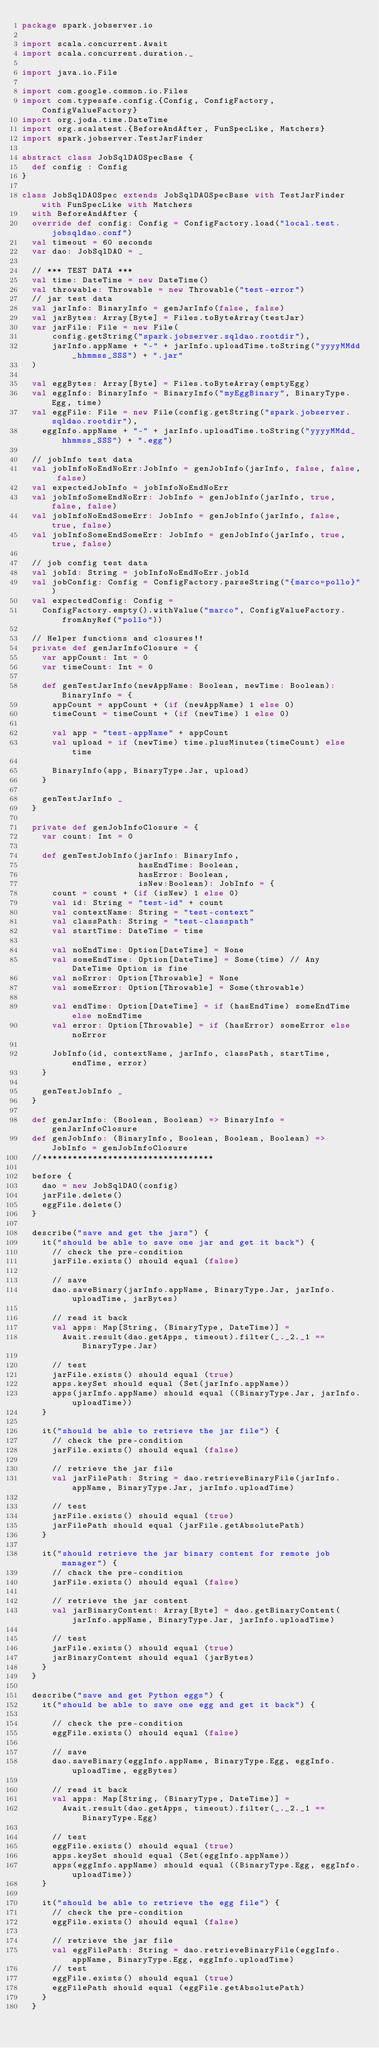Convert code to text. <code><loc_0><loc_0><loc_500><loc_500><_Scala_>package spark.jobserver.io

import scala.concurrent.Await
import scala.concurrent.duration._

import java.io.File

import com.google.common.io.Files
import com.typesafe.config.{Config, ConfigFactory, ConfigValueFactory}
import org.joda.time.DateTime
import org.scalatest.{BeforeAndAfter, FunSpecLike, Matchers}
import spark.jobserver.TestJarFinder

abstract class JobSqlDAOSpecBase {
  def config : Config
}

class JobSqlDAOSpec extends JobSqlDAOSpecBase with TestJarFinder with FunSpecLike with Matchers
  with BeforeAndAfter {
  override def config: Config = ConfigFactory.load("local.test.jobsqldao.conf")
  val timeout = 60 seconds
  var dao: JobSqlDAO = _

  // *** TEST DATA ***
  val time: DateTime = new DateTime()
  val throwable: Throwable = new Throwable("test-error")
  // jar test data
  val jarInfo: BinaryInfo = genJarInfo(false, false)
  val jarBytes: Array[Byte] = Files.toByteArray(testJar)
  var jarFile: File = new File(
      config.getString("spark.jobserver.sqldao.rootdir"),
      jarInfo.appName + "-" + jarInfo.uploadTime.toString("yyyyMMdd_hhmmss_SSS") + ".jar"
  )

  val eggBytes: Array[Byte] = Files.toByteArray(emptyEgg)
  val eggInfo: BinaryInfo = BinaryInfo("myEggBinary", BinaryType.Egg, time)
  val eggFile: File = new File(config.getString("spark.jobserver.sqldao.rootdir"),
    eggInfo.appName + "-" + jarInfo.uploadTime.toString("yyyyMMdd_hhmmss_SSS") + ".egg")

  // jobInfo test data
  val jobInfoNoEndNoErr:JobInfo = genJobInfo(jarInfo, false, false, false)
  val expectedJobInfo = jobInfoNoEndNoErr
  val jobInfoSomeEndNoErr: JobInfo = genJobInfo(jarInfo, true, false, false)
  val jobInfoNoEndSomeErr: JobInfo = genJobInfo(jarInfo, false, true, false)
  val jobInfoSomeEndSomeErr: JobInfo = genJobInfo(jarInfo, true, true, false)

  // job config test data
  val jobId: String = jobInfoNoEndNoErr.jobId
  val jobConfig: Config = ConfigFactory.parseString("{marco=pollo}")
  val expectedConfig: Config =
    ConfigFactory.empty().withValue("marco", ConfigValueFactory.fromAnyRef("pollo"))

  // Helper functions and closures!!
  private def genJarInfoClosure = {
    var appCount: Int = 0
    var timeCount: Int = 0

    def genTestJarInfo(newAppName: Boolean, newTime: Boolean): BinaryInfo = {
      appCount = appCount + (if (newAppName) 1 else 0)
      timeCount = timeCount + (if (newTime) 1 else 0)

      val app = "test-appName" + appCount
      val upload = if (newTime) time.plusMinutes(timeCount) else time

      BinaryInfo(app, BinaryType.Jar, upload)
    }

    genTestJarInfo _
  }

  private def genJobInfoClosure = {
    var count: Int = 0

    def genTestJobInfo(jarInfo: BinaryInfo,
                       hasEndTime: Boolean,
                       hasError: Boolean,
                       isNew:Boolean): JobInfo = {
      count = count + (if (isNew) 1 else 0)
      val id: String = "test-id" + count
      val contextName: String = "test-context"
      val classPath: String = "test-classpath"
      val startTime: DateTime = time

      val noEndTime: Option[DateTime] = None
      val someEndTime: Option[DateTime] = Some(time) // Any DateTime Option is fine
      val noError: Option[Throwable] = None
      val someError: Option[Throwable] = Some(throwable)

      val endTime: Option[DateTime] = if (hasEndTime) someEndTime else noEndTime
      val error: Option[Throwable] = if (hasError) someError else noError

      JobInfo(id, contextName, jarInfo, classPath, startTime, endTime, error)
    }

    genTestJobInfo _
  }

  def genJarInfo: (Boolean, Boolean) => BinaryInfo = genJarInfoClosure
  def genJobInfo: (BinaryInfo, Boolean, Boolean, Boolean) => JobInfo = genJobInfoClosure
  //**********************************

  before {
    dao = new JobSqlDAO(config)
    jarFile.delete()
    eggFile.delete()
  }

  describe("save and get the jars") {
    it("should be able to save one jar and get it back") {
      // check the pre-condition
      jarFile.exists() should equal (false)

      // save
      dao.saveBinary(jarInfo.appName, BinaryType.Jar, jarInfo.uploadTime, jarBytes)

      // read it back
      val apps: Map[String, (BinaryType, DateTime)] =
        Await.result(dao.getApps, timeout).filter(_._2._1 == BinaryType.Jar)

      // test
      jarFile.exists() should equal (true)
      apps.keySet should equal (Set(jarInfo.appName))
      apps(jarInfo.appName) should equal ((BinaryType.Jar, jarInfo.uploadTime))
    }

    it("should be able to retrieve the jar file") {
      // check the pre-condition
      jarFile.exists() should equal (false)

      // retrieve the jar file
      val jarFilePath: String = dao.retrieveBinaryFile(jarInfo.appName, BinaryType.Jar, jarInfo.uploadTime)

      // test
      jarFile.exists() should equal (true)
      jarFilePath should equal (jarFile.getAbsolutePath)
    }

    it("should retrieve the jar binary content for remote job manager") {
      // chack the pre-condition
      jarFile.exists() should equal (false)

      // retrieve the jar content
      val jarBinaryContent: Array[Byte] = dao.getBinaryContent(jarInfo.appName, BinaryType.Jar, jarInfo.uploadTime)

      // test
      jarFile.exists() should equal (true)
      jarBinaryContent should equal (jarBytes)
    }
  }

  describe("save and get Python eggs") {
    it("should be able to save one egg and get it back") {

      // check the pre-condition
      eggFile.exists() should equal (false)

      // save
      dao.saveBinary(eggInfo.appName, BinaryType.Egg, eggInfo.uploadTime, eggBytes)

      // read it back
      val apps: Map[String, (BinaryType, DateTime)] =
        Await.result(dao.getApps, timeout).filter(_._2._1 == BinaryType.Egg)

      // test
      eggFile.exists() should equal (true)
      apps.keySet should equal (Set(eggInfo.appName))
      apps(eggInfo.appName) should equal ((BinaryType.Egg, eggInfo.uploadTime))
    }

    it("should be able to retrieve the egg file") {
      // check the pre-condition
      eggFile.exists() should equal (false)

      // retrieve the jar file
      val eggFilePath: String = dao.retrieveBinaryFile(eggInfo.appName, BinaryType.Egg, eggInfo.uploadTime)
      // test
      eggFile.exists() should equal (true)
      eggFilePath should equal (eggFile.getAbsolutePath)
    }
  }
</code> 